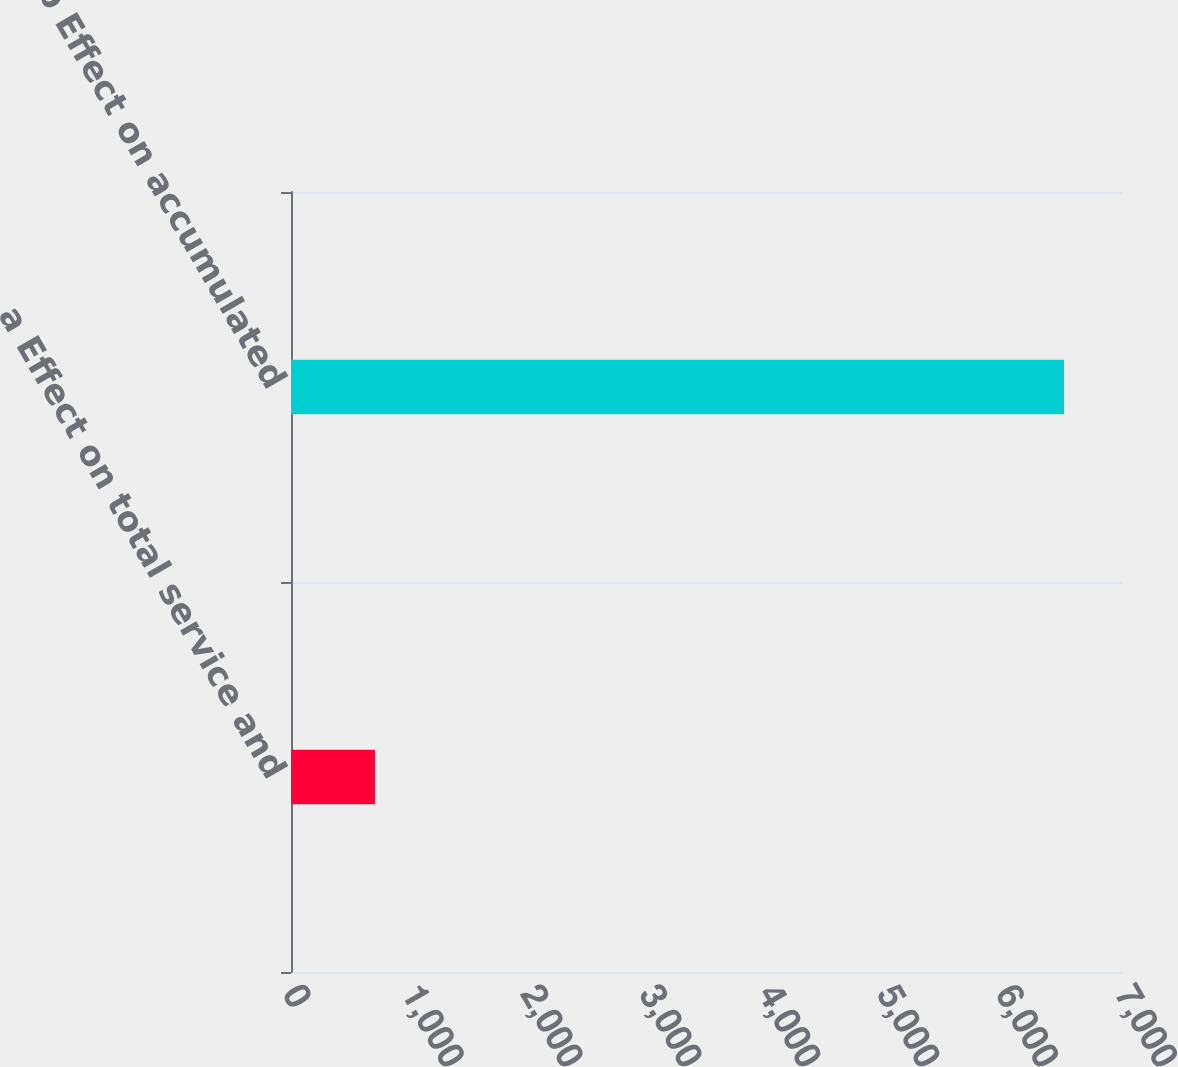Convert chart to OTSL. <chart><loc_0><loc_0><loc_500><loc_500><bar_chart><fcel>a Effect on total service and<fcel>b Effect on accumulated<nl><fcel>706<fcel>6504<nl></chart> 